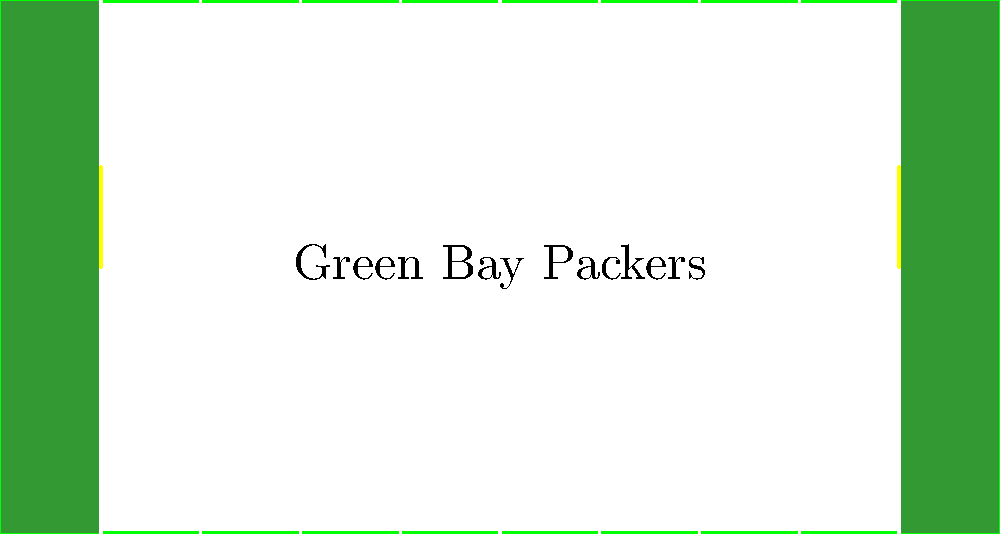As a digital artist creating fan art for the Green Bay Packers, you're working on a project that involves the geometry of a football field. Given that the standard NFL football field is 100 yards long (excluding end zones) and 53.3 yards wide, what is the total area of the playing field in square yards, including both end zones which are each 10 yards deep? Let's break this down step-by-step:

1. First, we need to calculate the total length of the field including end zones:
   * Main field length = 100 yards
   * Two end zones = 2 × 10 yards = 20 yards
   * Total length = 100 + 20 = 120 yards

2. We're given that the width of the field is 53.3 yards.

3. To calculate the area, we multiply the total length by the width:
   * Area = Length × Width
   * Area = 120 yards × 53.3 yards
   * Area = 6,396 square yards

Therefore, the total area of the playing field, including both end zones, is 6,396 square yards.
Answer: 6,396 square yards 